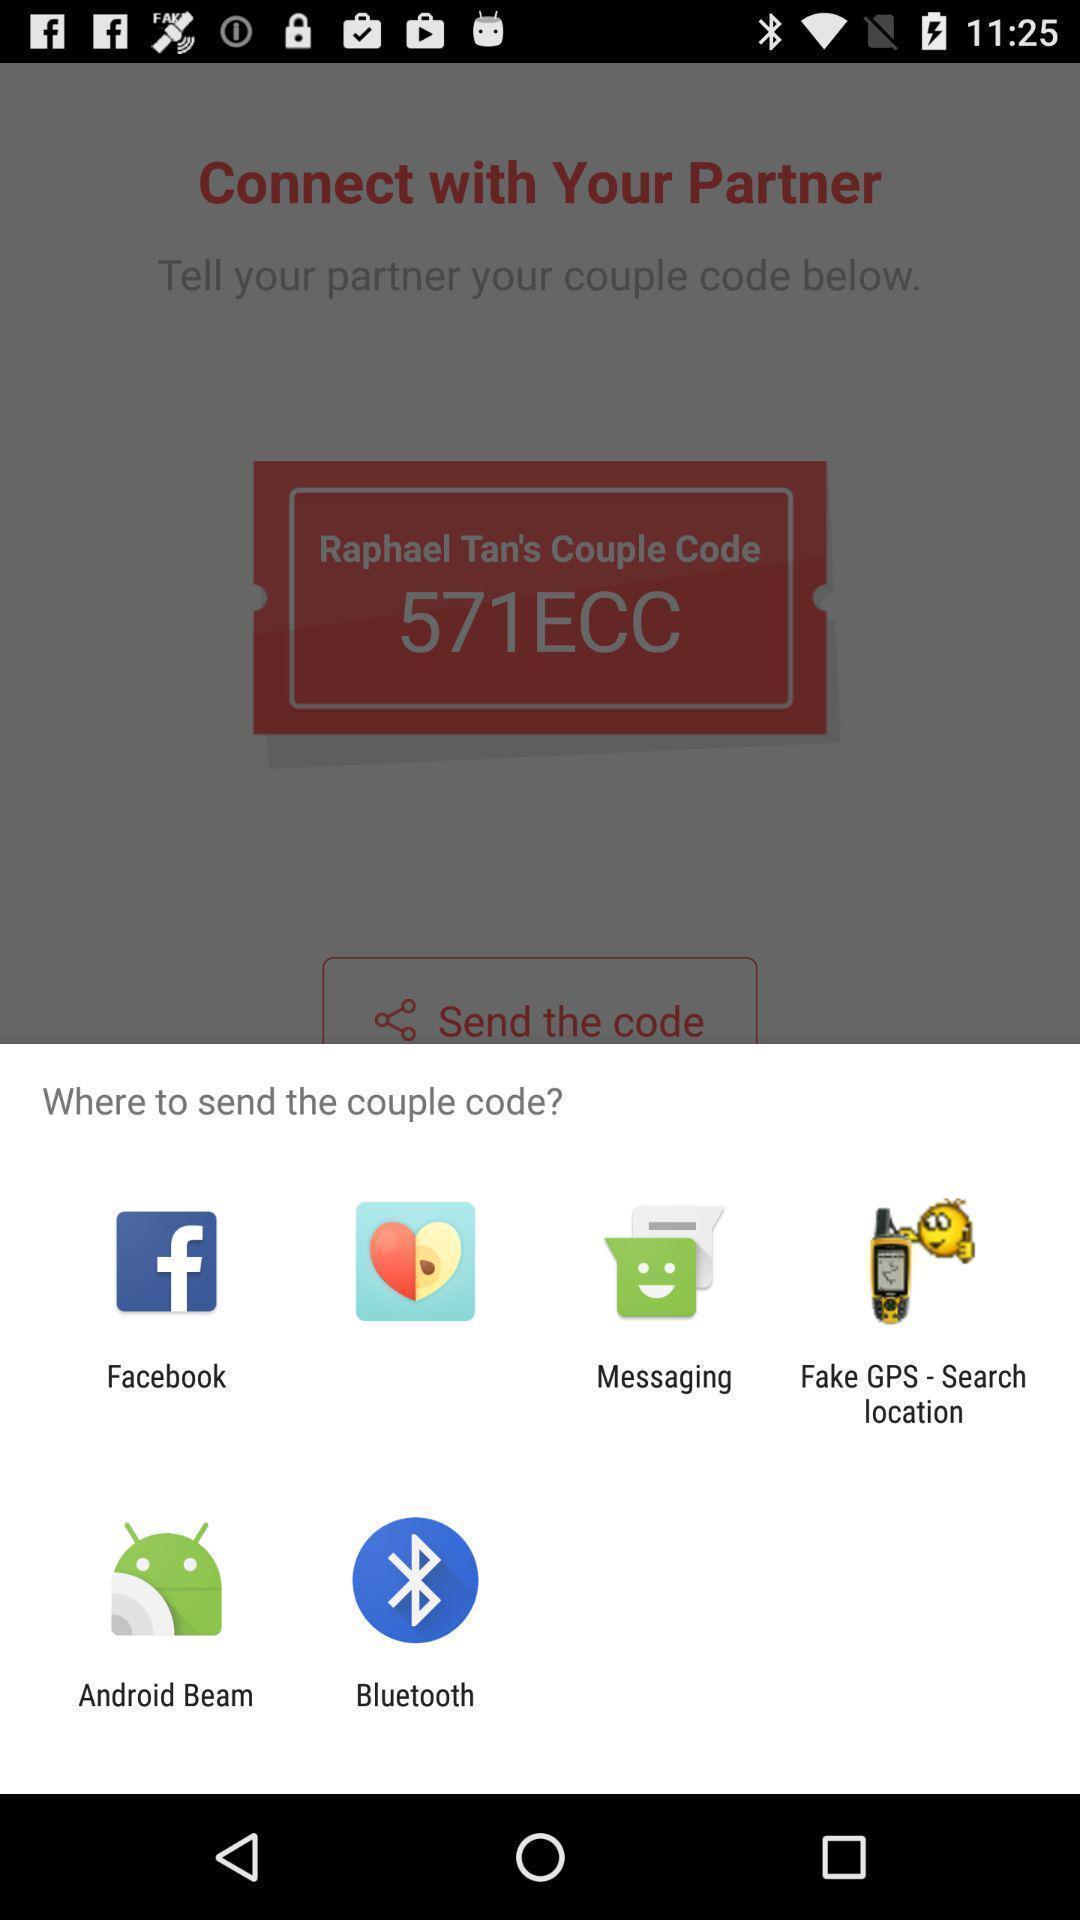Give me a narrative description of this picture. Pop-up to send code via different apps. 